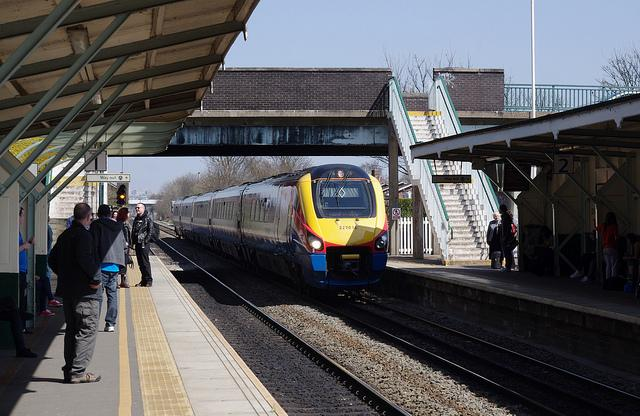Which platform services the train arriving now? right 